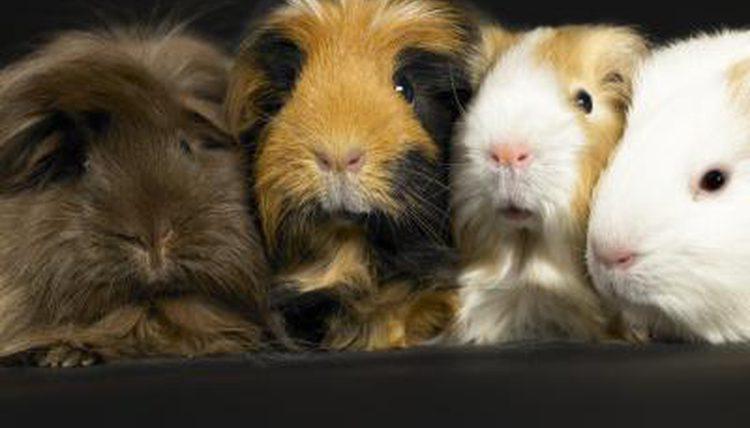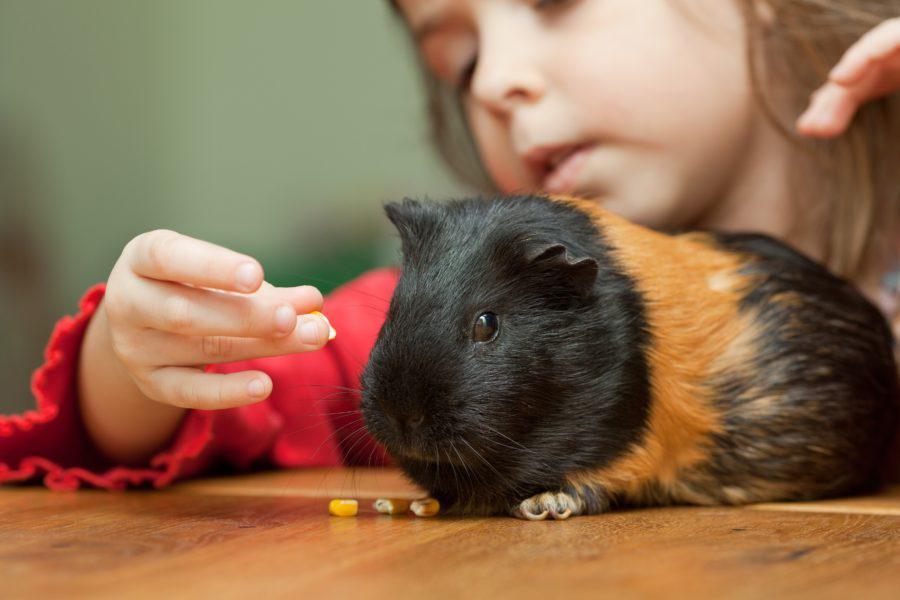The first image is the image on the left, the second image is the image on the right. Evaluate the accuracy of this statement regarding the images: "There is no more than one rodent in the left image.". Is it true? Answer yes or no. No. The first image is the image on the left, the second image is the image on the right. Analyze the images presented: Is the assertion "In one image, two guinea pigs have on green food item in both their mouths" valid? Answer yes or no. No. 